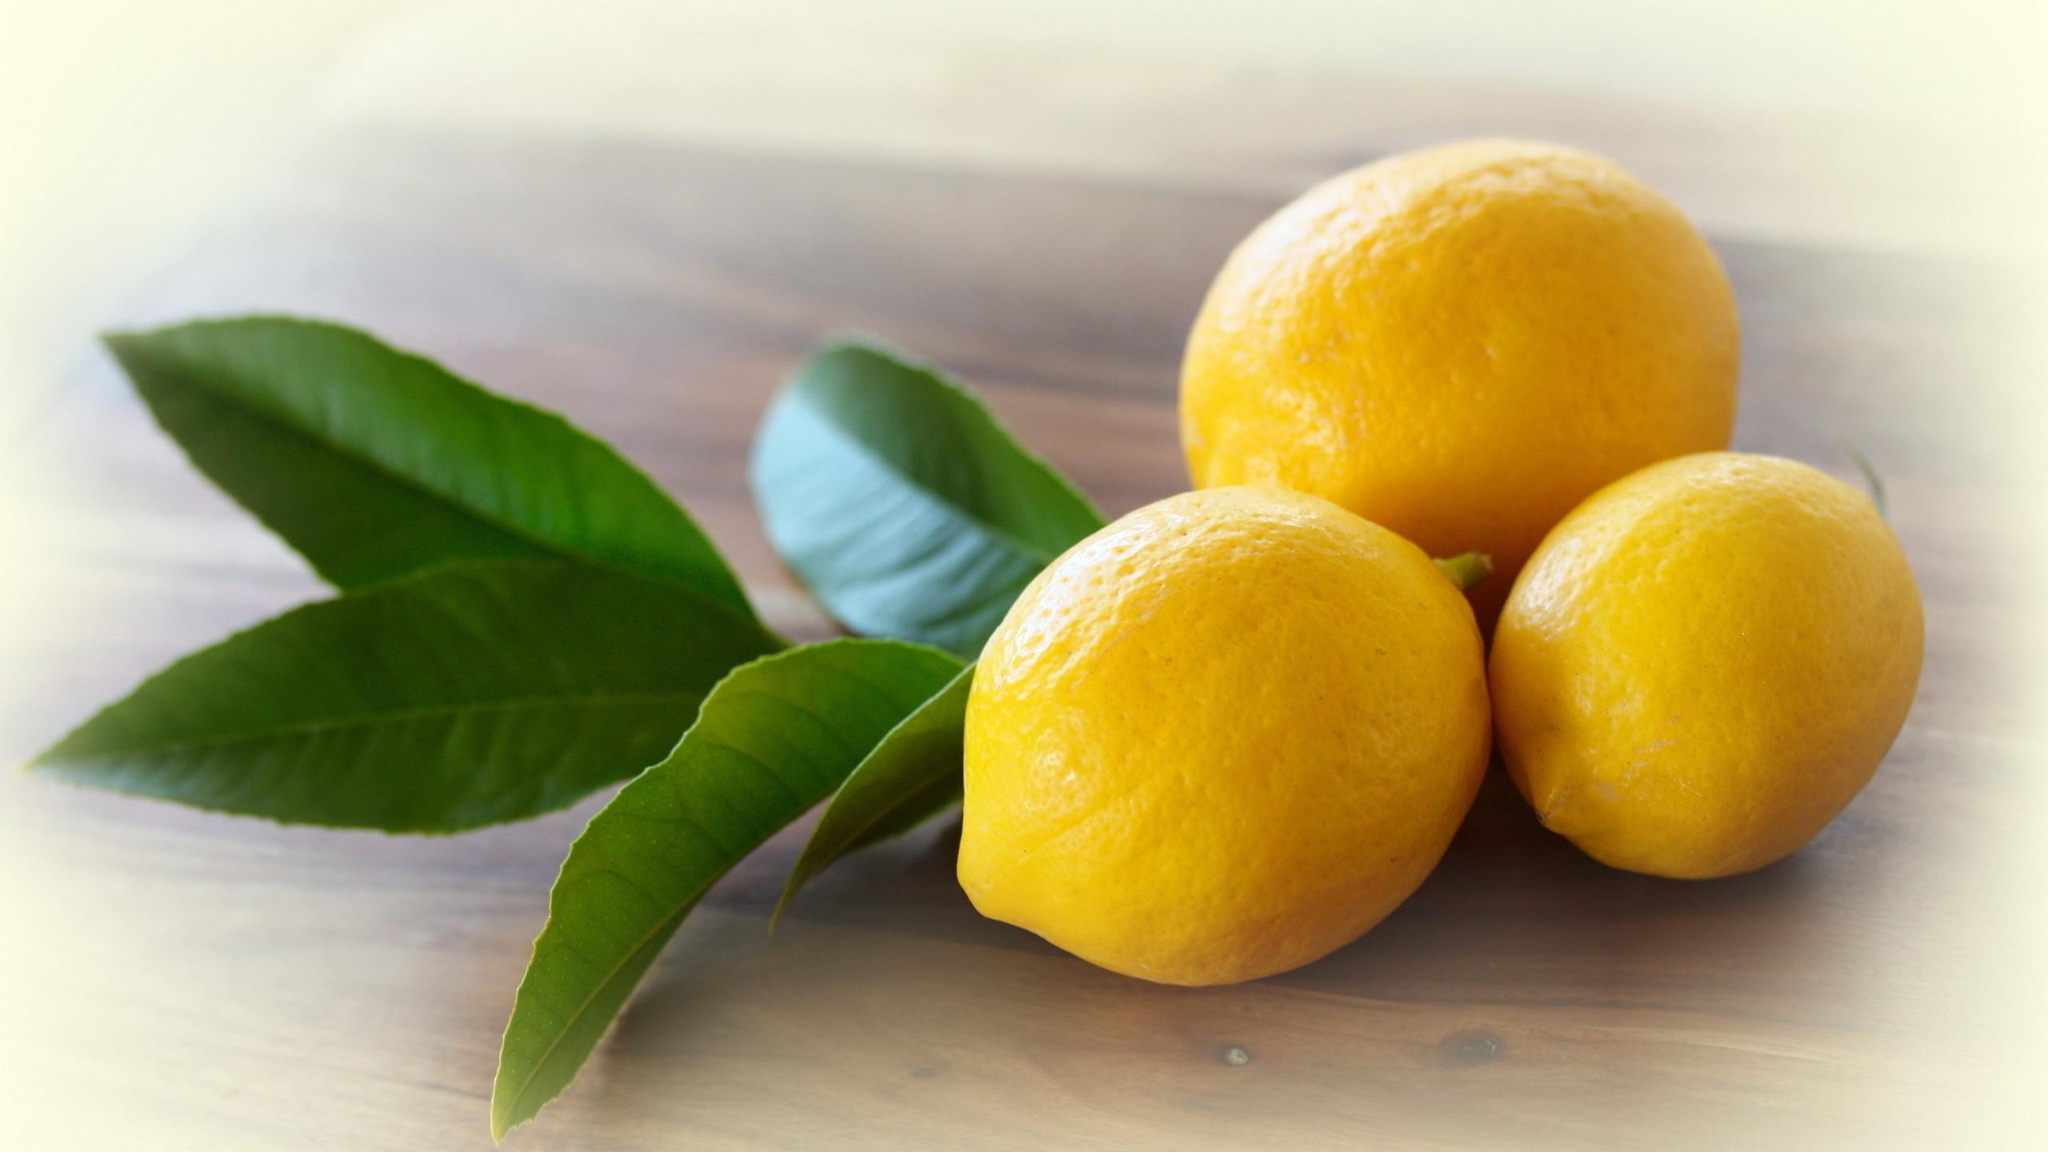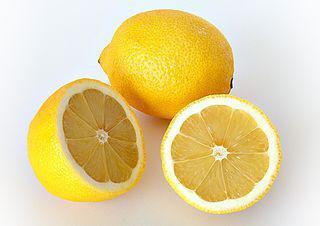The first image is the image on the left, the second image is the image on the right. Assess this claim about the two images: "There is one image with exactly five green leaves.". Correct or not? Answer yes or no. Yes. The first image is the image on the left, the second image is the image on the right. For the images displayed, is the sentence "in the left image the lemons are left whole" factually correct? Answer yes or no. Yes. 